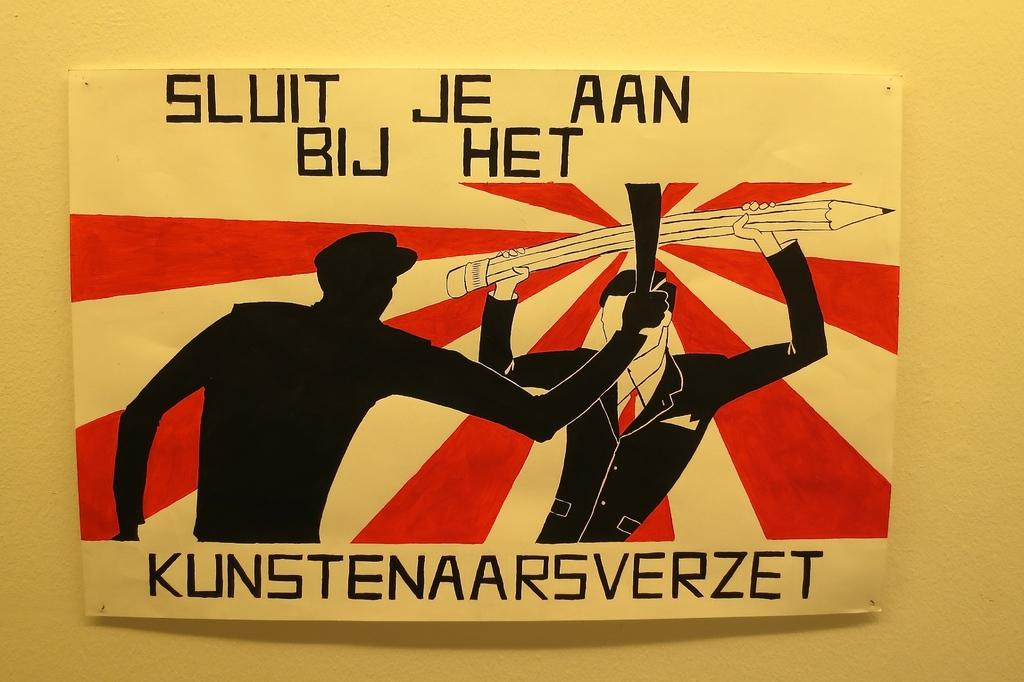Provide a one-sentence caption for the provided image. A painting in black, cream, and red shows two men and says, "Sluit Je Aan Bij Het". 